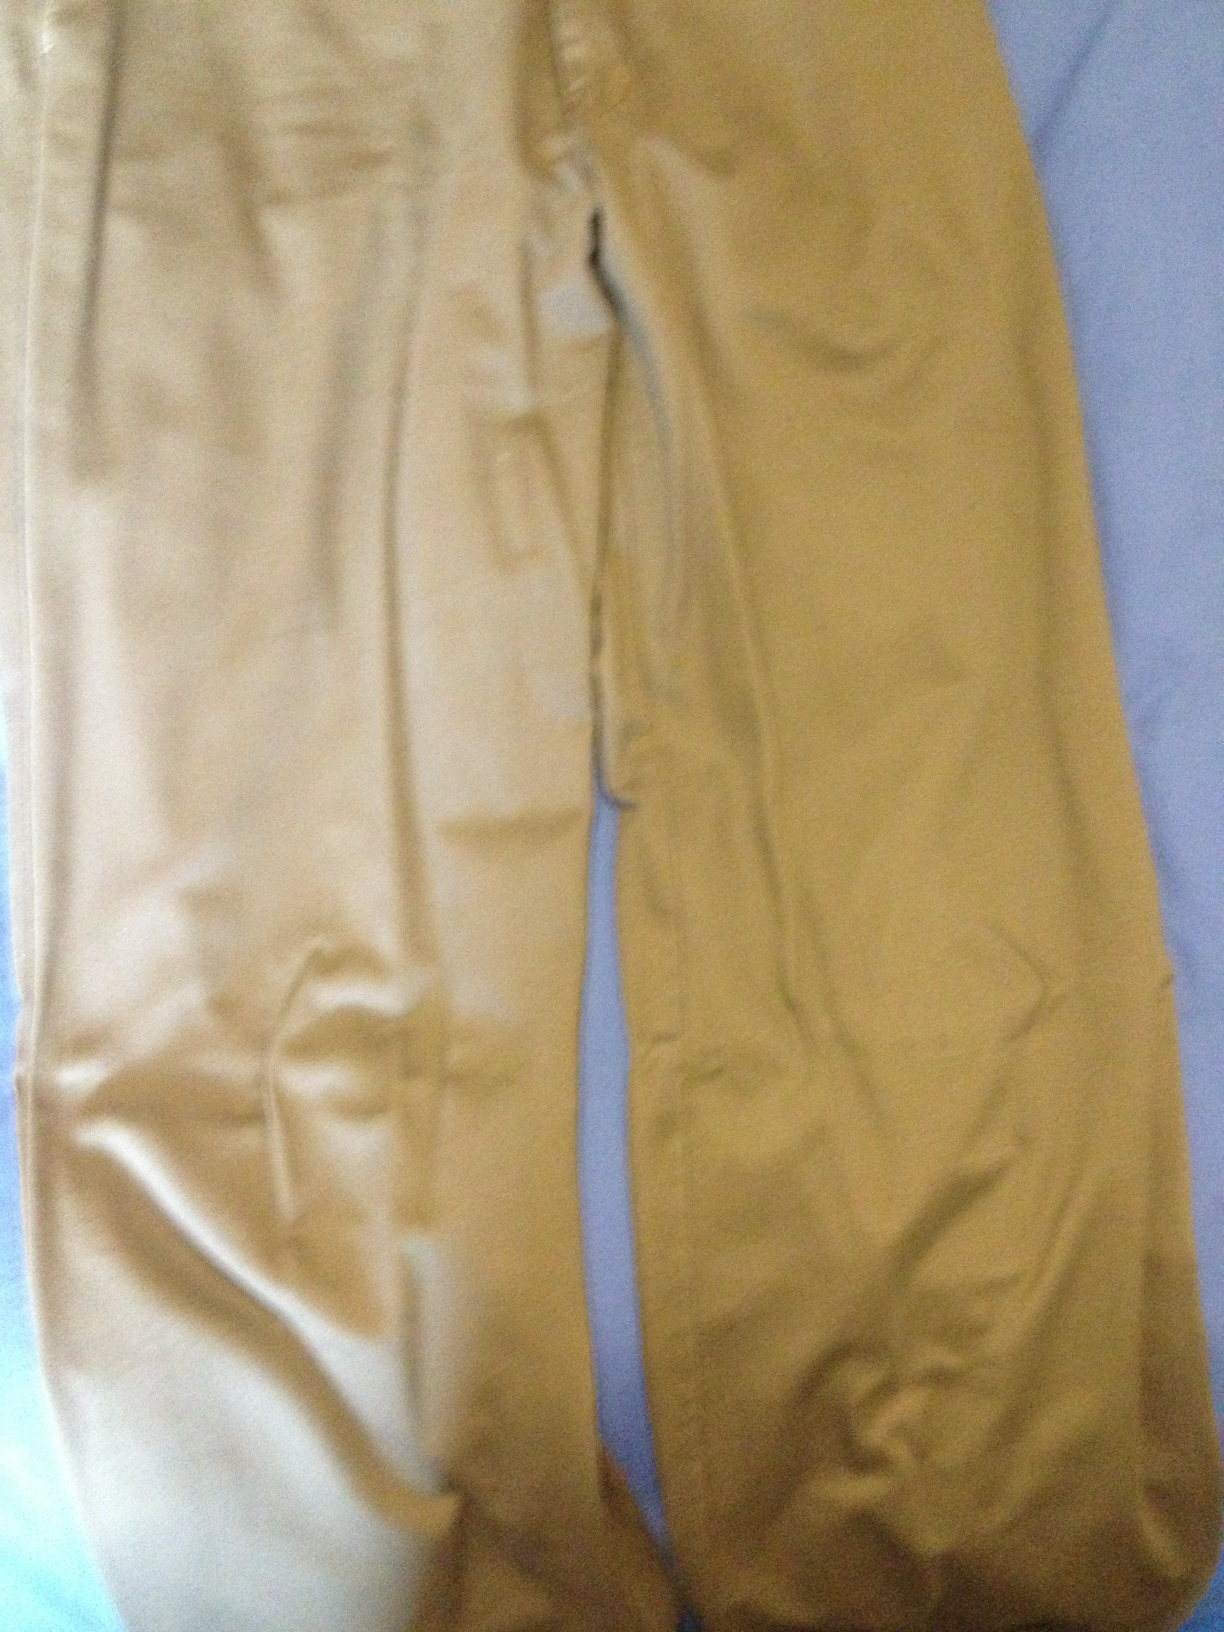Are these trousers suitable for a formal occasion? These trousers, with their solid khaki color and classic cut, could certainly be dressed up for a business casual setting. However, they might not be formal enough for events that require a suit or dress pants. 